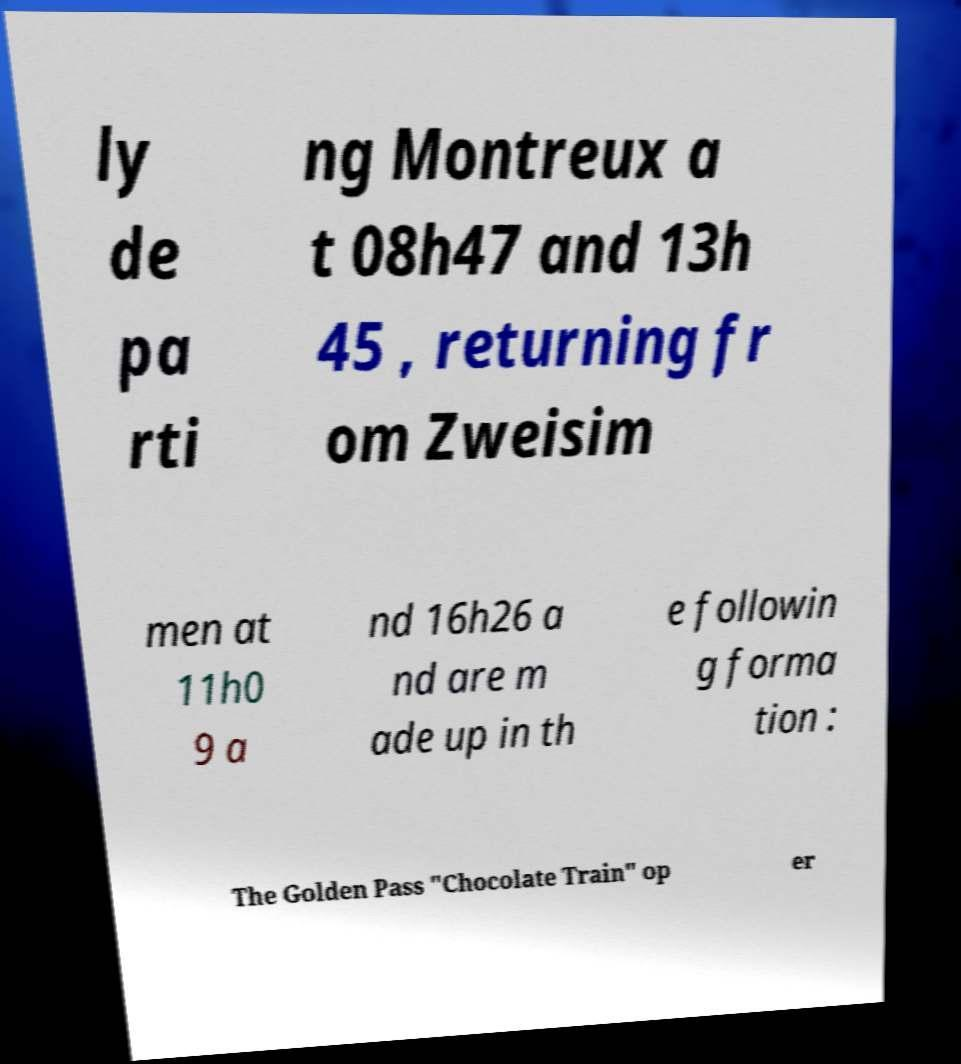What messages or text are displayed in this image? I need them in a readable, typed format. ly de pa rti ng Montreux a t 08h47 and 13h 45 , returning fr om Zweisim men at 11h0 9 a nd 16h26 a nd are m ade up in th e followin g forma tion : The Golden Pass "Chocolate Train" op er 